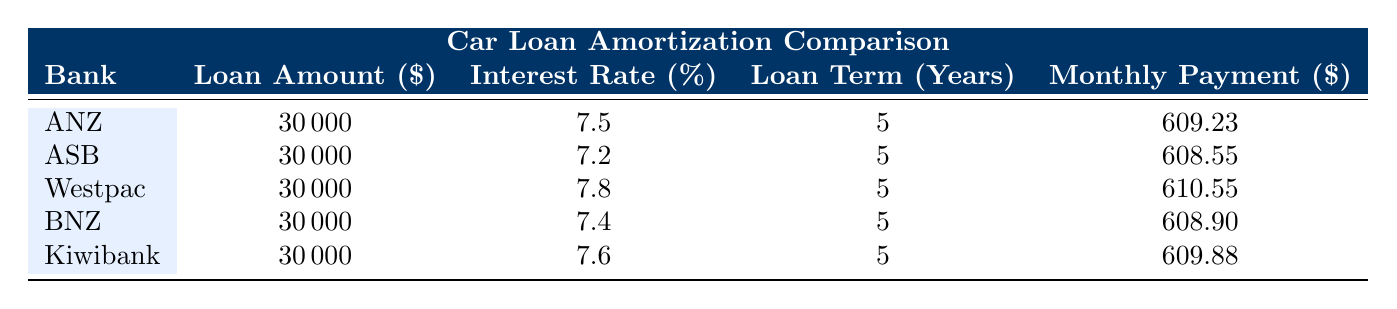What is the interest rate offered by ASB? According to the table, the interest rate for ASB is listed in the corresponding row, which shows that it is 7.2%.
Answer: 7.2% Which bank has the highest monthly payment for the car loan? The table shows the monthly payments for each bank. Comparing the values, Westpac has the highest monthly payment at 610.55.
Answer: Westpac What is the average interest rate among the banks? To find the average interest rate, sum the interest rates of all banks: (7.5 + 7.2 + 7.8 + 7.4 + 7.6) = 37.5. There are 5 banks, so the average interest rate is 37.5 / 5 = 7.5%.
Answer: 7.5% Is the monthly payment for a loan from Kiwibank less than that from ANZ? Kiwibank's monthly payment is 609.88, and ANZ's monthly payment is 609.23. Since 609.88 > 609.23, the statement is false.
Answer: No Which bank has the monthly payment closest to $610? By reviewing the monthly payments, both Westpac (610.55) and Kiwibank (609.88) are close to $610, but Westpac is closer.
Answer: Westpac 